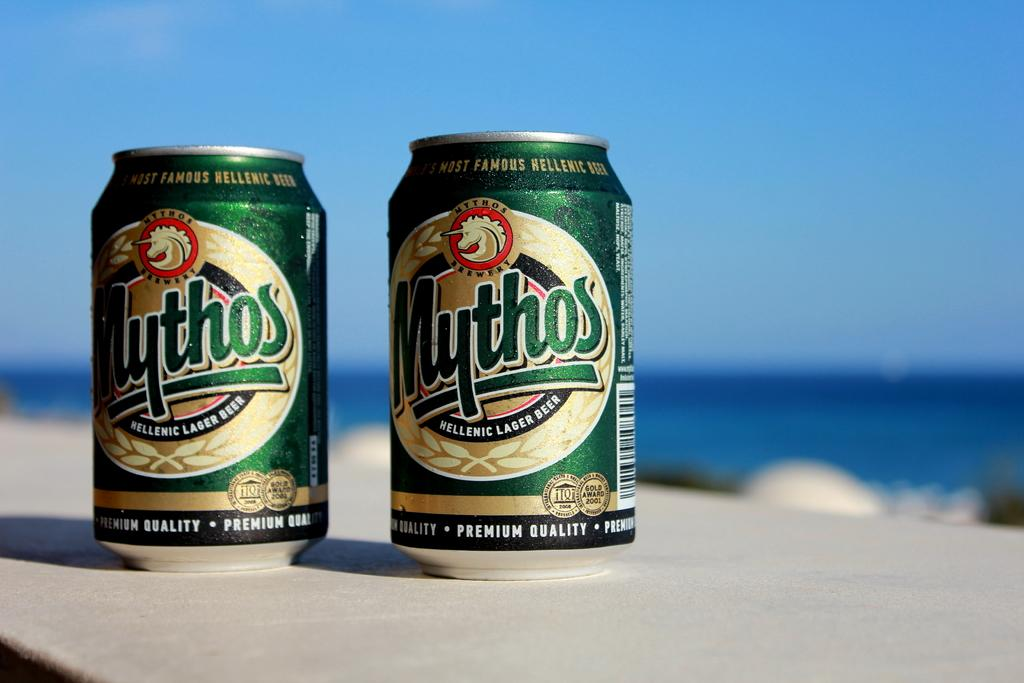Provide a one-sentence caption for the provided image. Two cans of mythos beer sit on a table at the beach. 